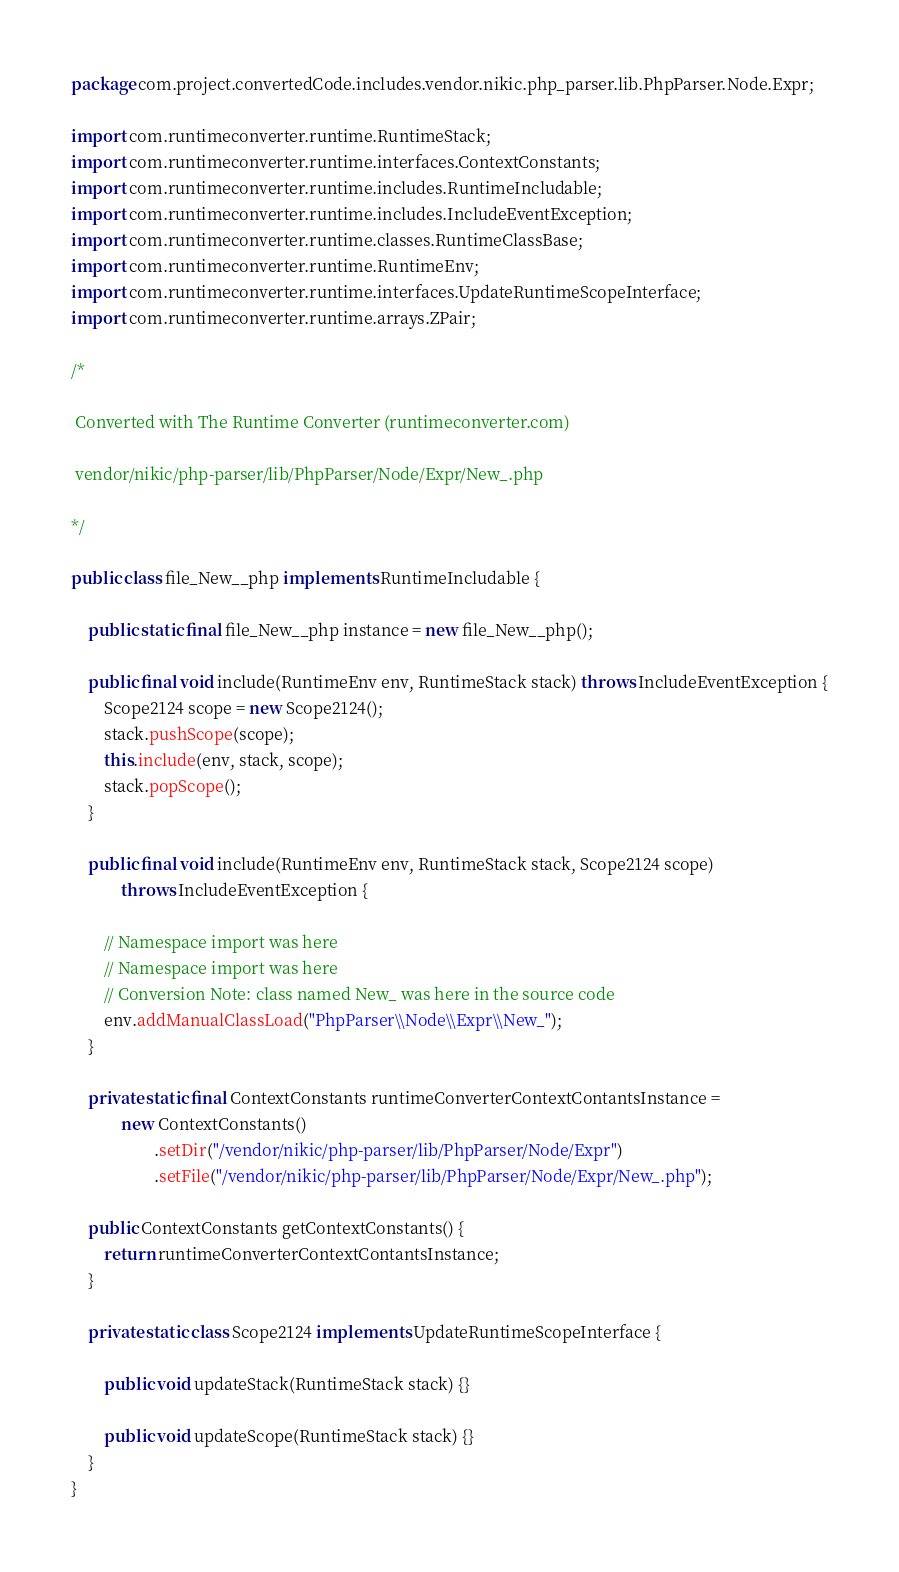<code> <loc_0><loc_0><loc_500><loc_500><_Java_>package com.project.convertedCode.includes.vendor.nikic.php_parser.lib.PhpParser.Node.Expr;

import com.runtimeconverter.runtime.RuntimeStack;
import com.runtimeconverter.runtime.interfaces.ContextConstants;
import com.runtimeconverter.runtime.includes.RuntimeIncludable;
import com.runtimeconverter.runtime.includes.IncludeEventException;
import com.runtimeconverter.runtime.classes.RuntimeClassBase;
import com.runtimeconverter.runtime.RuntimeEnv;
import com.runtimeconverter.runtime.interfaces.UpdateRuntimeScopeInterface;
import com.runtimeconverter.runtime.arrays.ZPair;

/*

 Converted with The Runtime Converter (runtimeconverter.com)

 vendor/nikic/php-parser/lib/PhpParser/Node/Expr/New_.php

*/

public class file_New__php implements RuntimeIncludable {

    public static final file_New__php instance = new file_New__php();

    public final void include(RuntimeEnv env, RuntimeStack stack) throws IncludeEventException {
        Scope2124 scope = new Scope2124();
        stack.pushScope(scope);
        this.include(env, stack, scope);
        stack.popScope();
    }

    public final void include(RuntimeEnv env, RuntimeStack stack, Scope2124 scope)
            throws IncludeEventException {

        // Namespace import was here
        // Namespace import was here
        // Conversion Note: class named New_ was here in the source code
        env.addManualClassLoad("PhpParser\\Node\\Expr\\New_");
    }

    private static final ContextConstants runtimeConverterContextContantsInstance =
            new ContextConstants()
                    .setDir("/vendor/nikic/php-parser/lib/PhpParser/Node/Expr")
                    .setFile("/vendor/nikic/php-parser/lib/PhpParser/Node/Expr/New_.php");

    public ContextConstants getContextConstants() {
        return runtimeConverterContextContantsInstance;
    }

    private static class Scope2124 implements UpdateRuntimeScopeInterface {

        public void updateStack(RuntimeStack stack) {}

        public void updateScope(RuntimeStack stack) {}
    }
}
</code> 